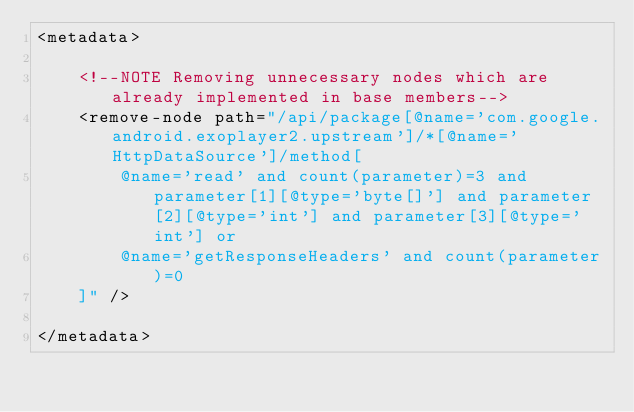Convert code to text. <code><loc_0><loc_0><loc_500><loc_500><_XML_><metadata>

    <!--NOTE Removing unnecessary nodes which are already implemented in base members-->
    <remove-node path="/api/package[@name='com.google.android.exoplayer2.upstream']/*[@name='HttpDataSource']/method[
        @name='read' and count(parameter)=3 and parameter[1][@type='byte[]'] and parameter[2][@type='int'] and parameter[3][@type='int'] or
        @name='getResponseHeaders' and count(parameter)=0
    ]" />

</metadata>
</code> 